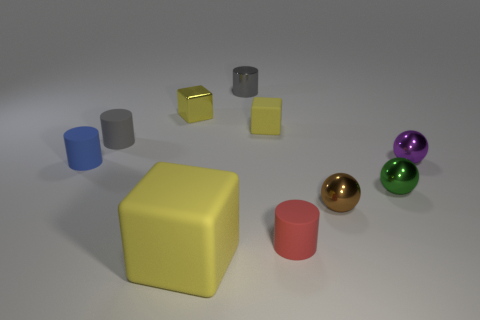Is there a green thing of the same size as the red rubber cylinder?
Your answer should be compact. Yes. The matte cylinder that is right of the yellow object in front of the small object to the left of the gray rubber cylinder is what color?
Offer a very short reply. Red. Are the tiny red cylinder and the tiny object that is on the right side of the small green object made of the same material?
Make the answer very short. No. There is another metallic object that is the same shape as the large thing; what size is it?
Your response must be concise. Small. Are there an equal number of tiny red rubber things behind the small yellow shiny block and purple spheres in front of the large yellow thing?
Provide a succinct answer. Yes. How many other things are there of the same material as the green object?
Offer a very short reply. 4. Are there an equal number of small cylinders on the right side of the small purple sphere and objects?
Your response must be concise. No. Does the brown object have the same size as the sphere behind the small blue object?
Ensure brevity in your answer.  Yes. The small object on the right side of the small green thing has what shape?
Offer a terse response. Sphere. Is there any other thing that has the same shape as the tiny gray matte thing?
Give a very brief answer. Yes. 